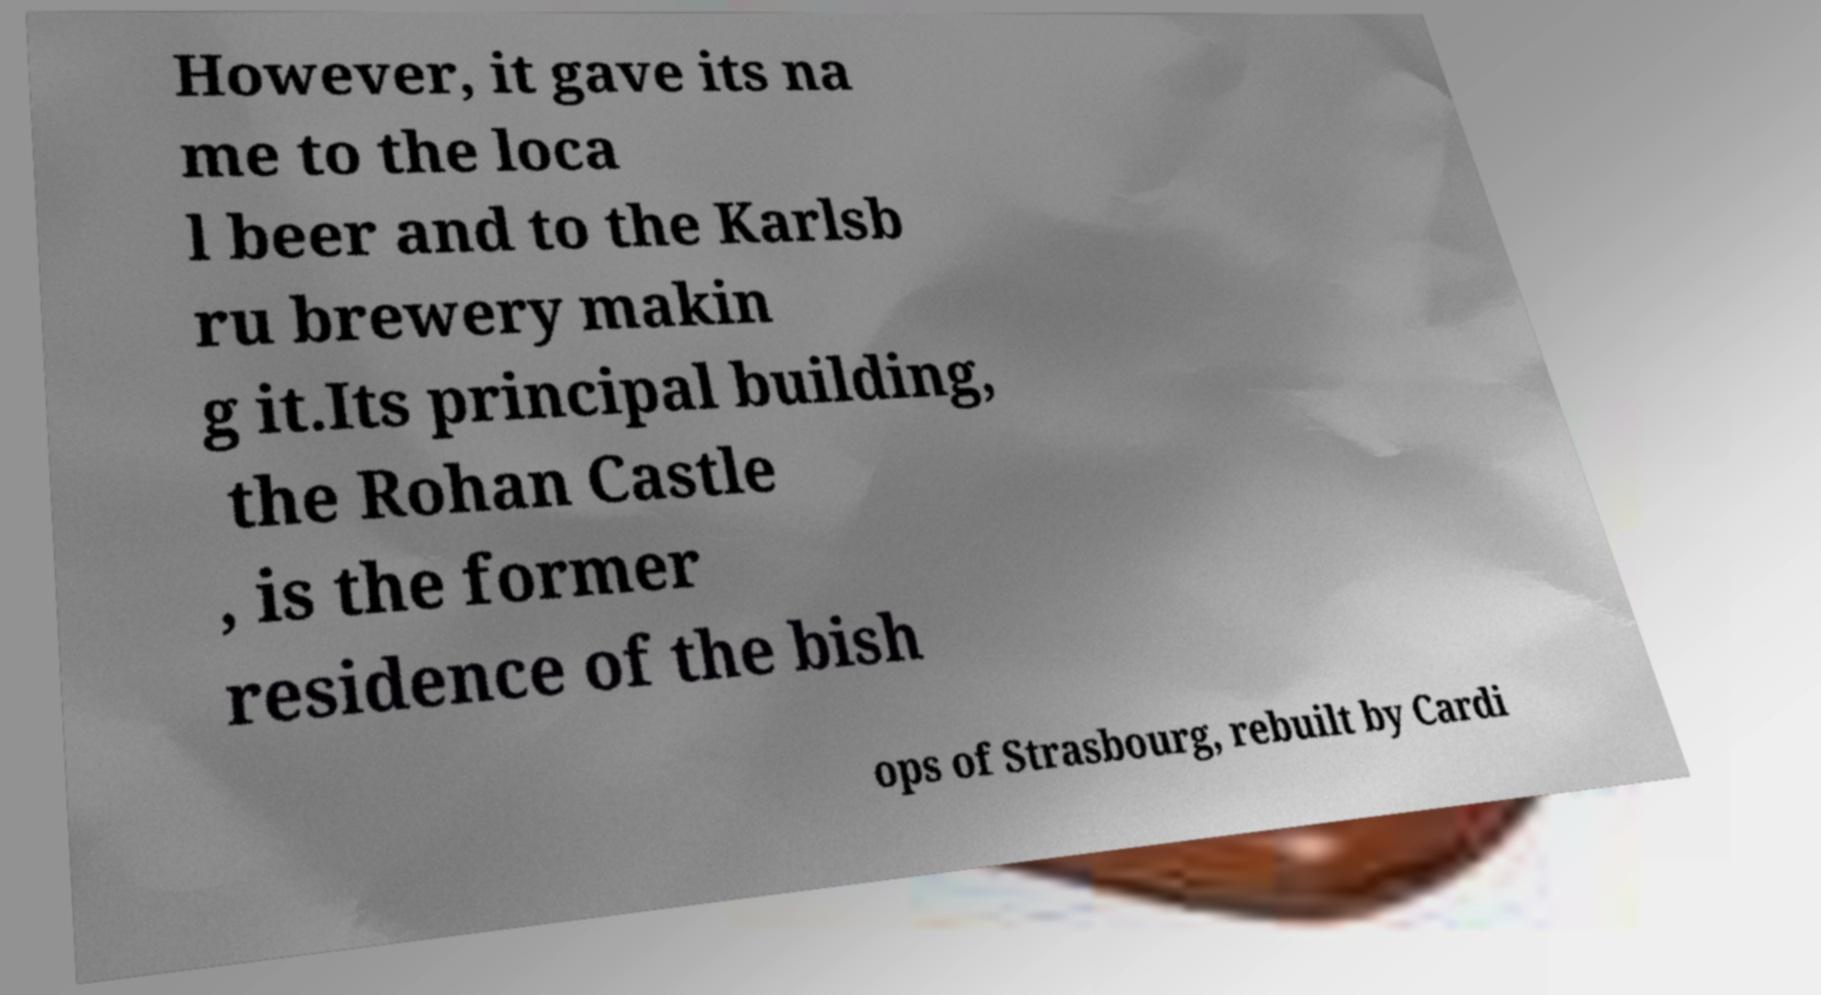What messages or text are displayed in this image? I need them in a readable, typed format. However, it gave its na me to the loca l beer and to the Karlsb ru brewery makin g it.Its principal building, the Rohan Castle , is the former residence of the bish ops of Strasbourg, rebuilt by Cardi 